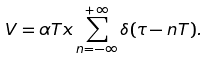<formula> <loc_0><loc_0><loc_500><loc_500>V = \alpha T x \sum _ { n = - \infty } ^ { + \infty } \delta ( \tau - n T ) .</formula> 